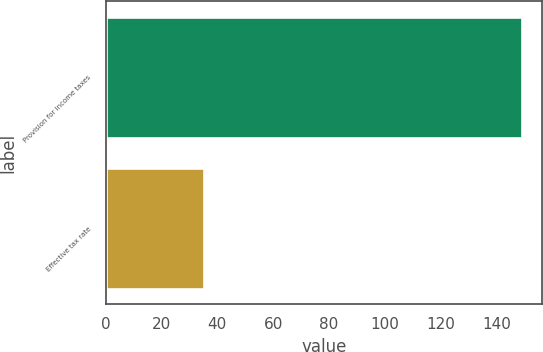Convert chart to OTSL. <chart><loc_0><loc_0><loc_500><loc_500><bar_chart><fcel>Provision for income taxes<fcel>Effective tax rate<nl><fcel>148.9<fcel>35.3<nl></chart> 